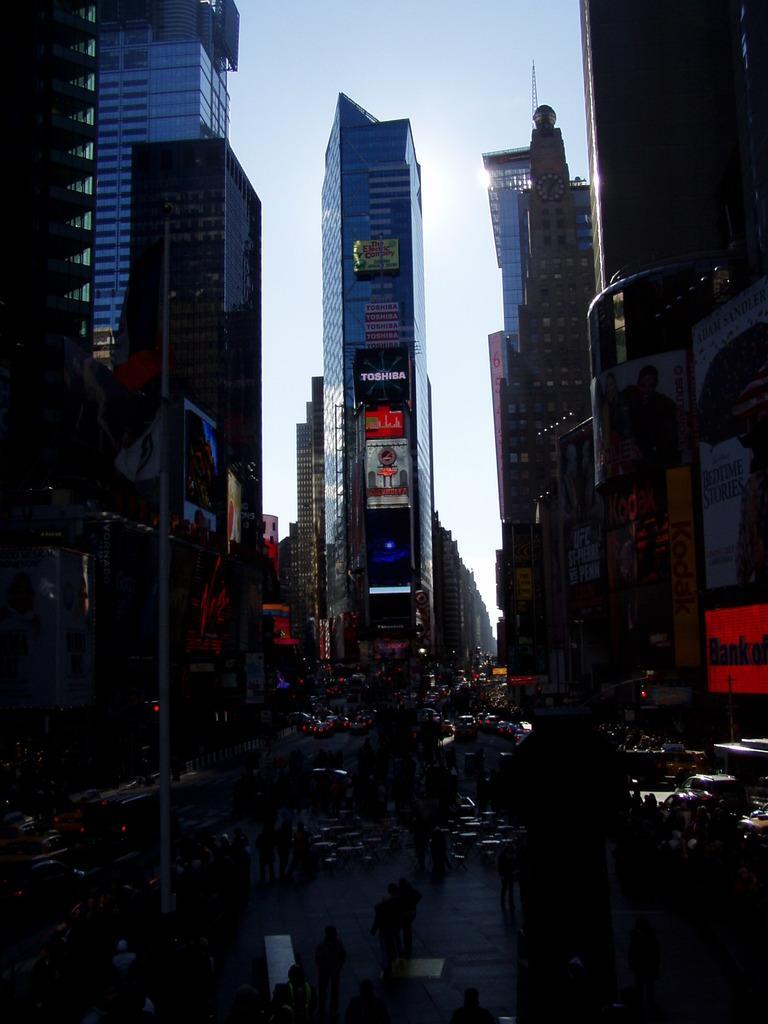Can you describe this image briefly? In the picture I can see buildings, vehicles on the road and some other objects on the ground. In the background I can see the sky. This image is little bit dark. 